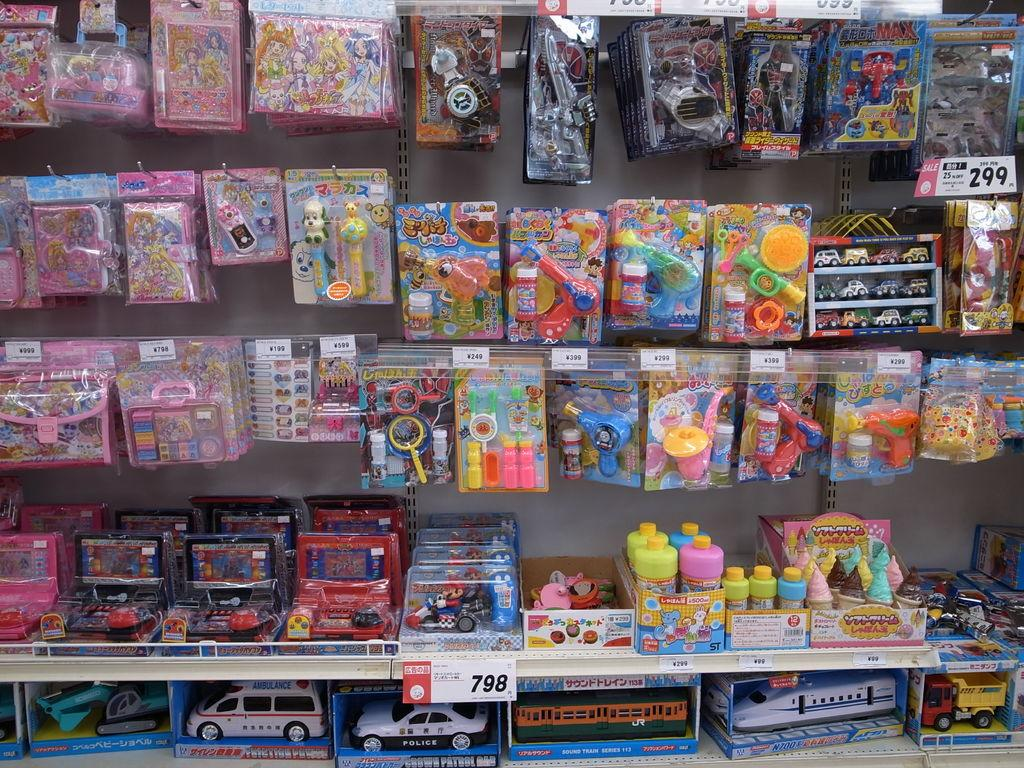<image>
Relay a brief, clear account of the picture shown. A toy display at a store with prices shown at 299 and 798. 